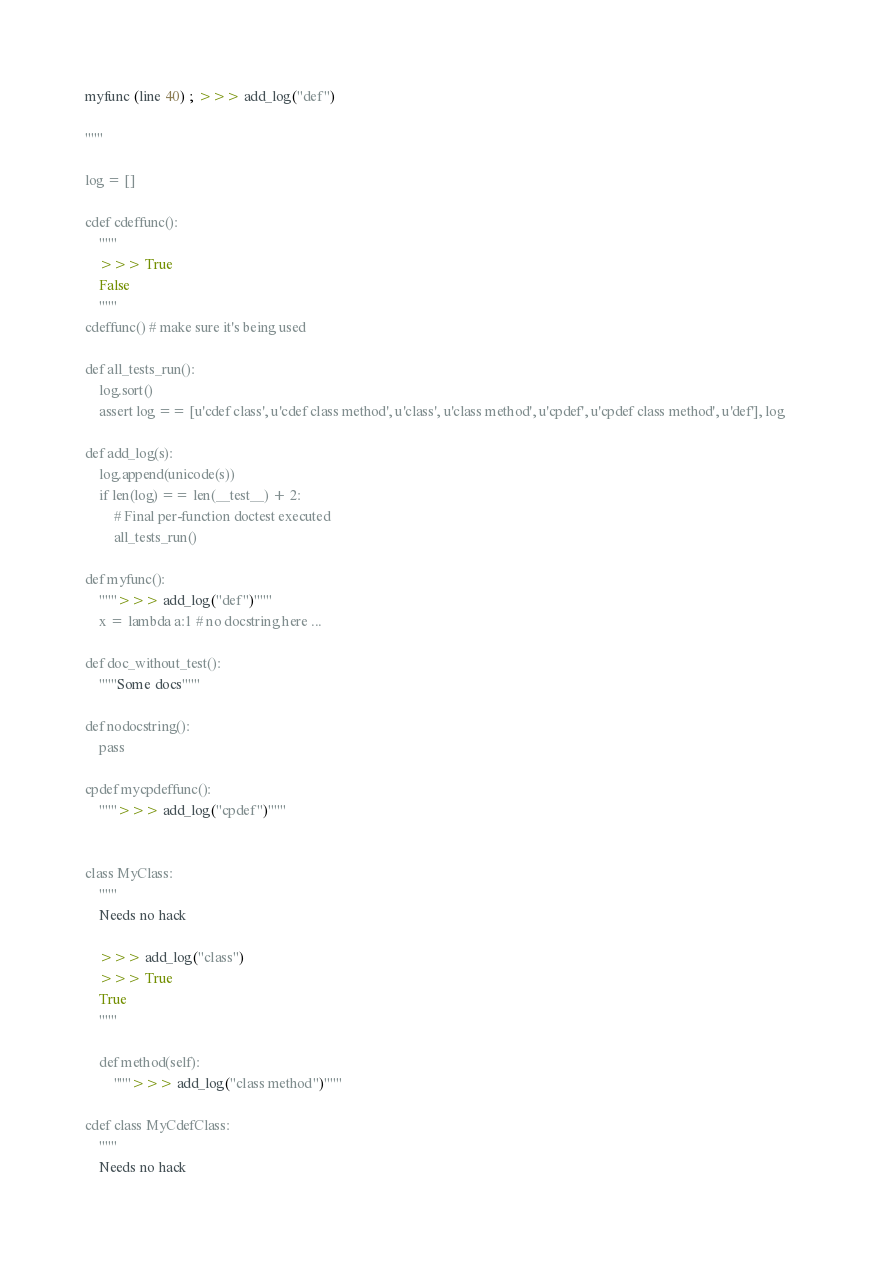<code> <loc_0><loc_0><loc_500><loc_500><_Cython_>myfunc (line 40) ; >>> add_log("def")

"""

log = []

cdef cdeffunc():
    """
    >>> True
    False
    """
cdeffunc() # make sure it's being used

def all_tests_run():
    log.sort()
    assert log == [u'cdef class', u'cdef class method', u'class', u'class method', u'cpdef', u'cpdef class method', u'def'], log

def add_log(s):
    log.append(unicode(s))
    if len(log) == len(__test__) + 2:
        # Final per-function doctest executed
        all_tests_run()

def myfunc():
    """>>> add_log("def")"""
    x = lambda a:1 # no docstring here ...

def doc_without_test():
    """Some docs"""

def nodocstring():
    pass

cpdef mycpdeffunc():
    """>>> add_log("cpdef")"""


class MyClass:
    """
    Needs no hack

    >>> add_log("class")
    >>> True
    True
    """

    def method(self):
        """>>> add_log("class method")"""

cdef class MyCdefClass:
    """
    Needs no hack
</code> 